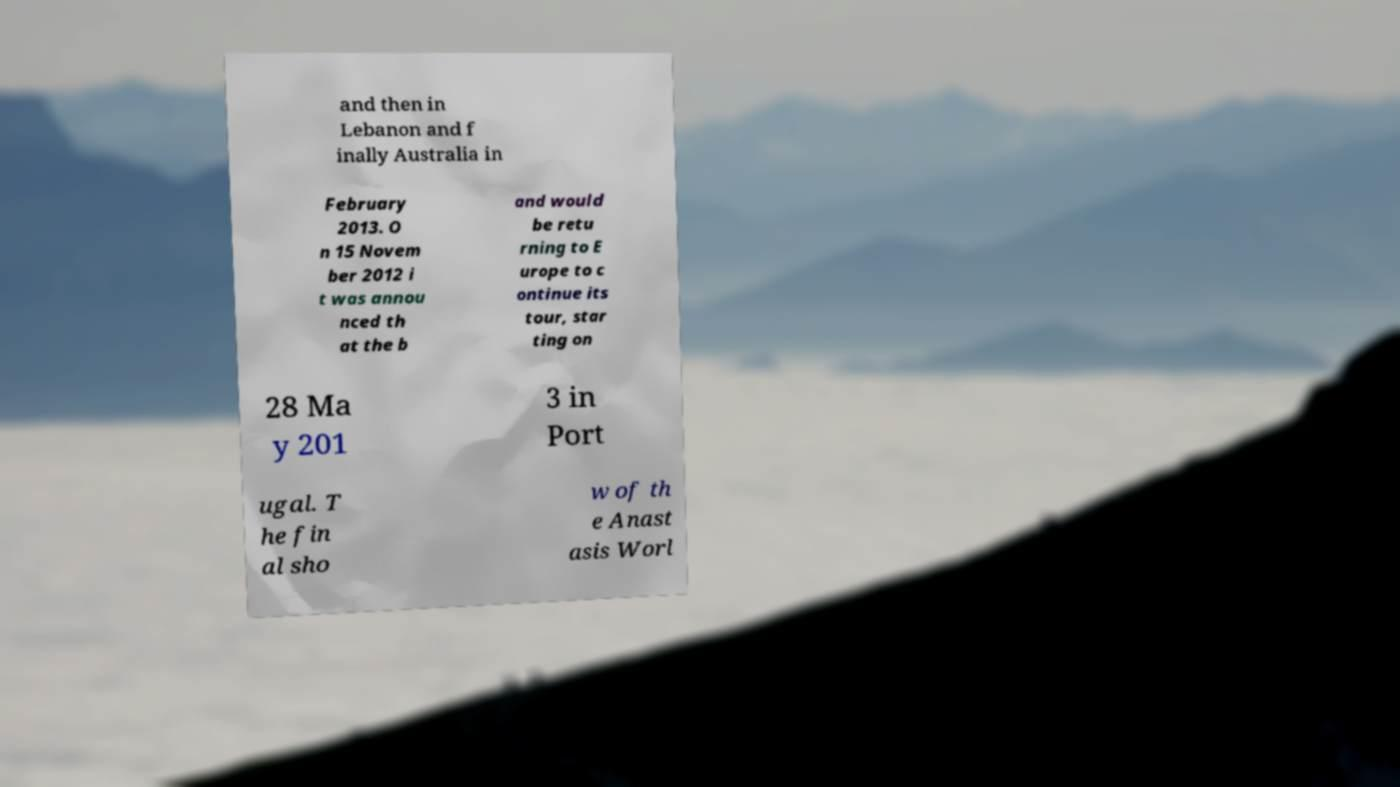There's text embedded in this image that I need extracted. Can you transcribe it verbatim? and then in Lebanon and f inally Australia in February 2013. O n 15 Novem ber 2012 i t was annou nced th at the b and would be retu rning to E urope to c ontinue its tour, star ting on 28 Ma y 201 3 in Port ugal. T he fin al sho w of th e Anast asis Worl 